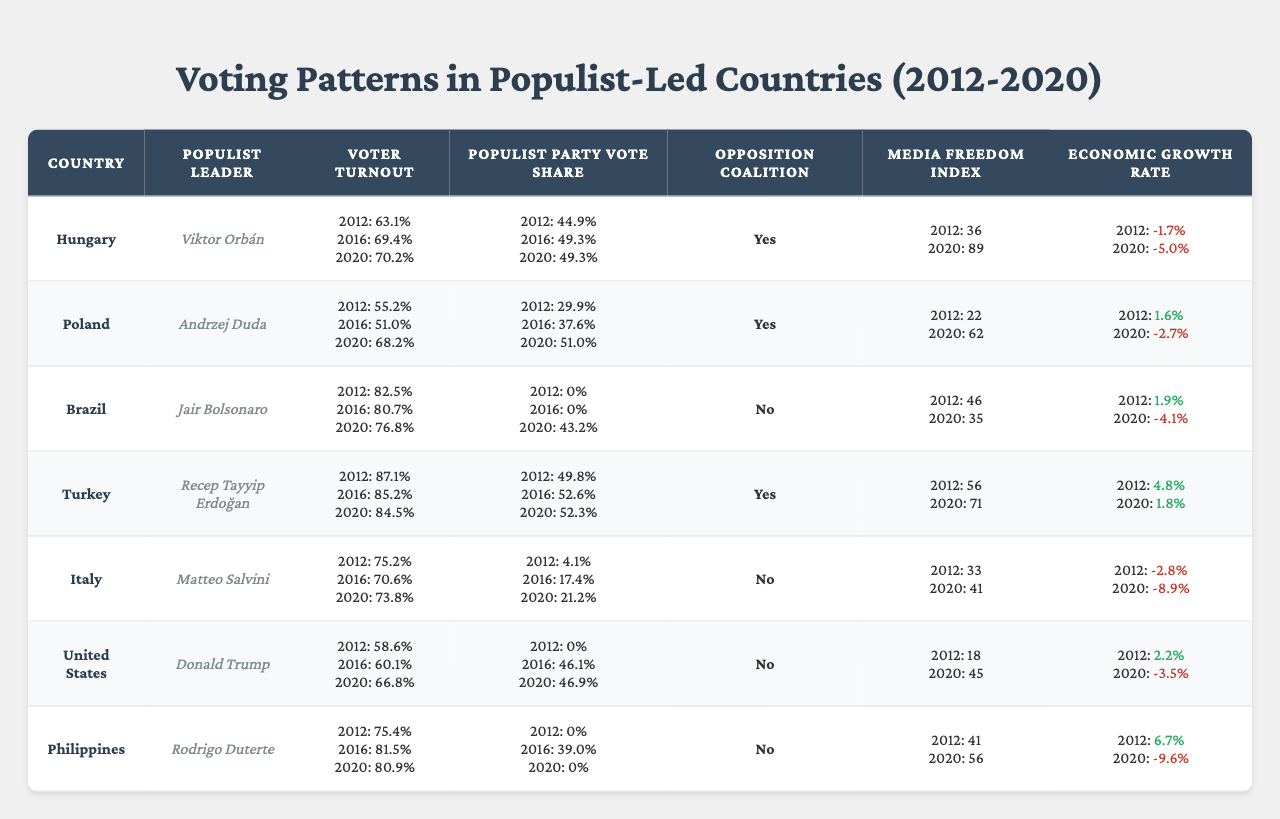What was the voter turnout for Brazil in 2020? Looking at the row for Brazil, the "2020 Voter Turnout" column shows 76.8%.
Answer: 76.8% Which country had the highest voter turnout in 2016? By examining the "2016 Voter Turnout" column, Hungary had the highest turnout rate at 69.4%.
Answer: Hungary Did any of the listed populist-led countries have a coalition formed against their populist leader? Checking the "Opposition Coalition" column, Hungary, Poland, and Turkey all had coalitions formed, indicating a "Yes" answer.
Answer: Yes What was the change in the media freedom index for the United States from 2012 to 2020? The media freedom index for the United States was 18 in 2012 and rose to 45 in 2020, resulting in a change of (45 - 18) = 27.
Answer: 27 What is the average voter turnout across all countries for the year 2020? Adding the turnout percentages for 2020 yields (70.2 + 68.2 + 76.8 + 84.5 + 73.8 + 66.8 + 80.9) = 520.2, then dividing by the number of countries (7) gives an average of 74.3.
Answer: 74.3 Which country had the lowest Economic Growth Rate in 2020? Looking at the "Economic Growth Rate 2020" column, the lowest value is -9.6% for the Philippines.
Answer: Philippines What was the pattern in the populist party vote share for Italy from 2012 to 2020? Italy's vote share changed from 4.1% in 2012 to 17.4% in 2016 and 21.2% in 2020, indicating a steady increase over the years.
Answer: Steady increase Did any country experience an increase in voter turnout from 2012 to 2020? Analyzing the voter turnout data, Hungary, the United States, and the Philippines all had increased turnout from 63.1% in 2012 to 70.2%, 58.6% to 66.8%, and 75.4% to 80.9% respectively.
Answer: Yes What was the populist party vote share for Turkey in 2020 compared to 2012? Turkey's populist party vote share was 49.8% in 2012 and slightly decreased to 52.3% in 2020.
Answer: Increased Which populist leader had the highest voter turnout in their country for 2020? Checking the 2020 voter turnout column,Recep Tayyip Erdoğan in Turkey had 84.5%, which is the highest.
Answer: Recep Tayyip Erdoğan 